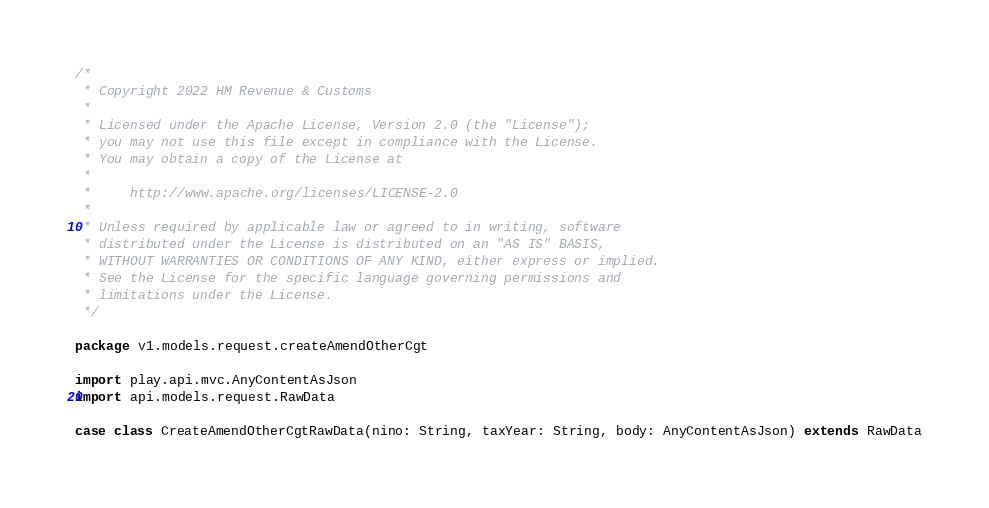<code> <loc_0><loc_0><loc_500><loc_500><_Scala_>/*
 * Copyright 2022 HM Revenue & Customs
 *
 * Licensed under the Apache License, Version 2.0 (the "License");
 * you may not use this file except in compliance with the License.
 * You may obtain a copy of the License at
 *
 *     http://www.apache.org/licenses/LICENSE-2.0
 *
 * Unless required by applicable law or agreed to in writing, software
 * distributed under the License is distributed on an "AS IS" BASIS,
 * WITHOUT WARRANTIES OR CONDITIONS OF ANY KIND, either express or implied.
 * See the License for the specific language governing permissions and
 * limitations under the License.
 */

package v1.models.request.createAmendOtherCgt

import play.api.mvc.AnyContentAsJson
import api.models.request.RawData

case class CreateAmendOtherCgtRawData(nino: String, taxYear: String, body: AnyContentAsJson) extends RawData
</code> 